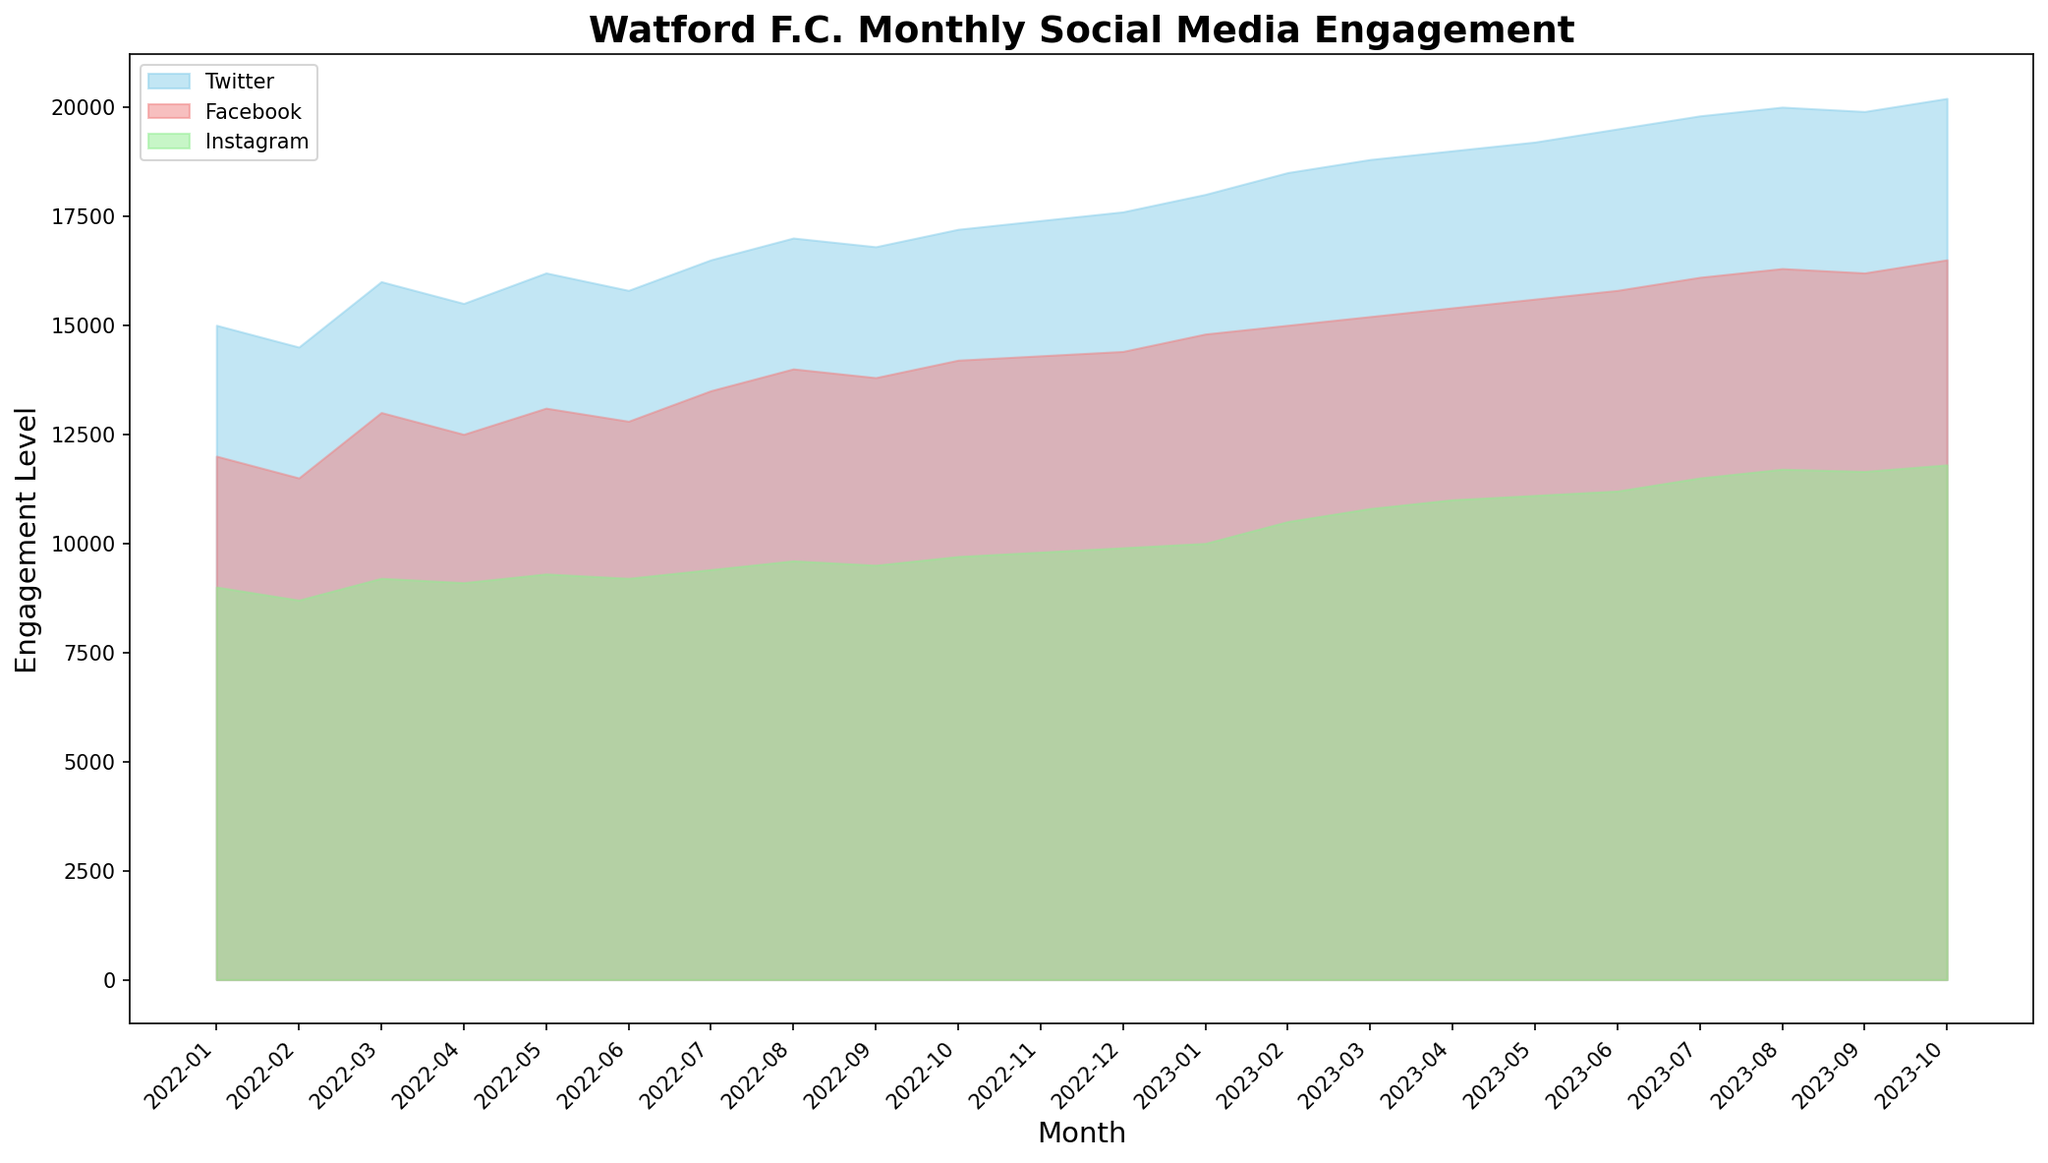What's the trend of Twitter engagements from January 2022 to October 2023? The Twitter engagement levels show a generally increasing trend, starting from 15,000 in January 2022 and ending with 20,200 in October 2023, with minor fluctuations in between.
Answer: Increasing trend During which month did Instagram engagements first surpass 10,000? Instagram engagements first surpassed 10,000 in January 2023, where it reached exactly 10,000.
Answer: January 2023 Which month had the highest combined total engagement for all platforms, and what was the total engagement? October 2023 had the highest combined total engagement for all platforms. The total engagement is 20,200 (Twitter) + 16,500 (Facebook) + 11,800 (Instagram) = 48,500.
Answer: October 2023, 48,500 What's the average monthly engagement for Instagram over the entire period? Sum the Instagram engagements from January 2022 to October 2023 and divide by the number of months (22): (9,000 + 8,700 + 9,200 + 9,100 + 9,300 + 9,200 + 9,400 + 9,600 + 9,500 + 9,700 + 9,800 + 9,900 + 10,000 + 10,500 + 10,800 + 11,000 + 11,100 + 11,200 + 11,500 + 11,700 + 11,650 + 11,800) / 22 = 10,320.
Answer: 10,320 